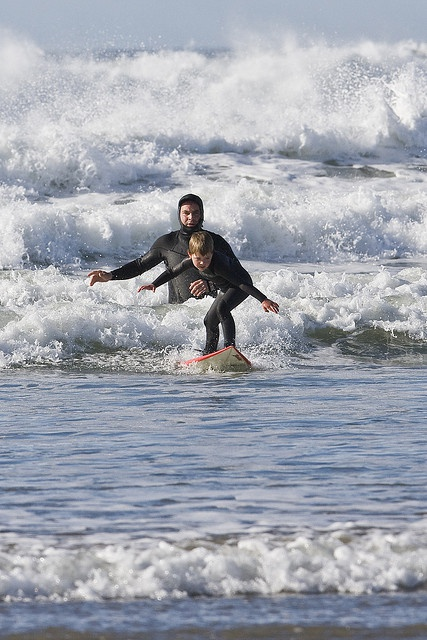Describe the objects in this image and their specific colors. I can see people in darkgray, black, lightgray, and gray tones, people in darkgray, black, gray, maroon, and lightgray tones, and surfboard in darkgray, gray, and lightpink tones in this image. 